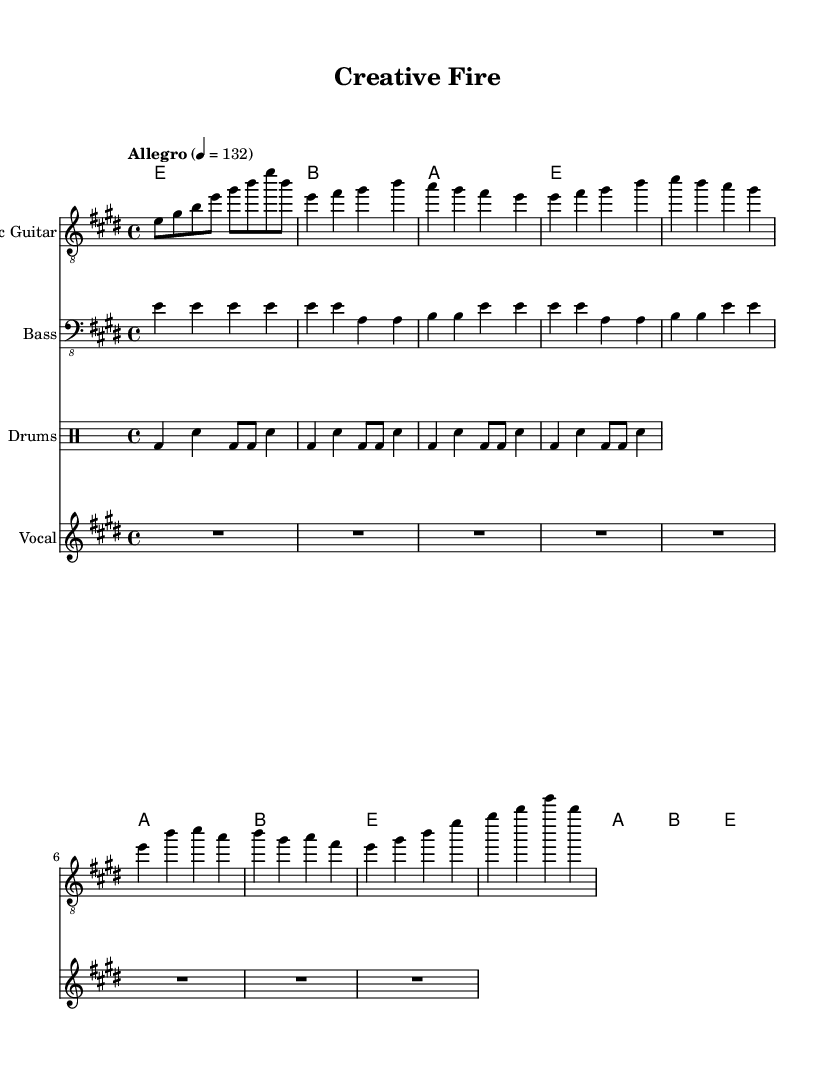What is the key signature of this music? The key signature shows two sharps, which indicates that it is in the key of E major.
Answer: E major What is the time signature of the piece? The time signature is found at the beginning of the score after the key signature and indicates how many beats are in a measure, which is 4/4 in this case.
Answer: 4/4 What tempo marking is indicated for this composition? The tempo marking is located above the staff and indicates the speed of the piece; here it shows "Allegro" with a metronome marking of 132 beats per minute.
Answer: Allegro, 132 How many measures are in the intro section? By counting the measures in the intro part that is explicitly noted in the electric guitar part, we can determine that there are 4 measures.
Answer: 4 What is the predominant rhythmic element used in the drum part? The drum part features a repeated rock beat pattern, which often consists of bass drums and snare hits in a consistent sequence throughout.
Answer: Rock beat What is the chord progression used in the chorus? By analyzing the chords written above the respective measures, the progression in the chorus can be seen to follow E major to A major to B major, then back to E major.
Answer: E, A, B, E How is the vocal line represented in the sheet music? The vocal line is represented with rests throughout the indicated measures, which suggests it is either not yet composed or meant to be filled in later.
Answer: Rests 